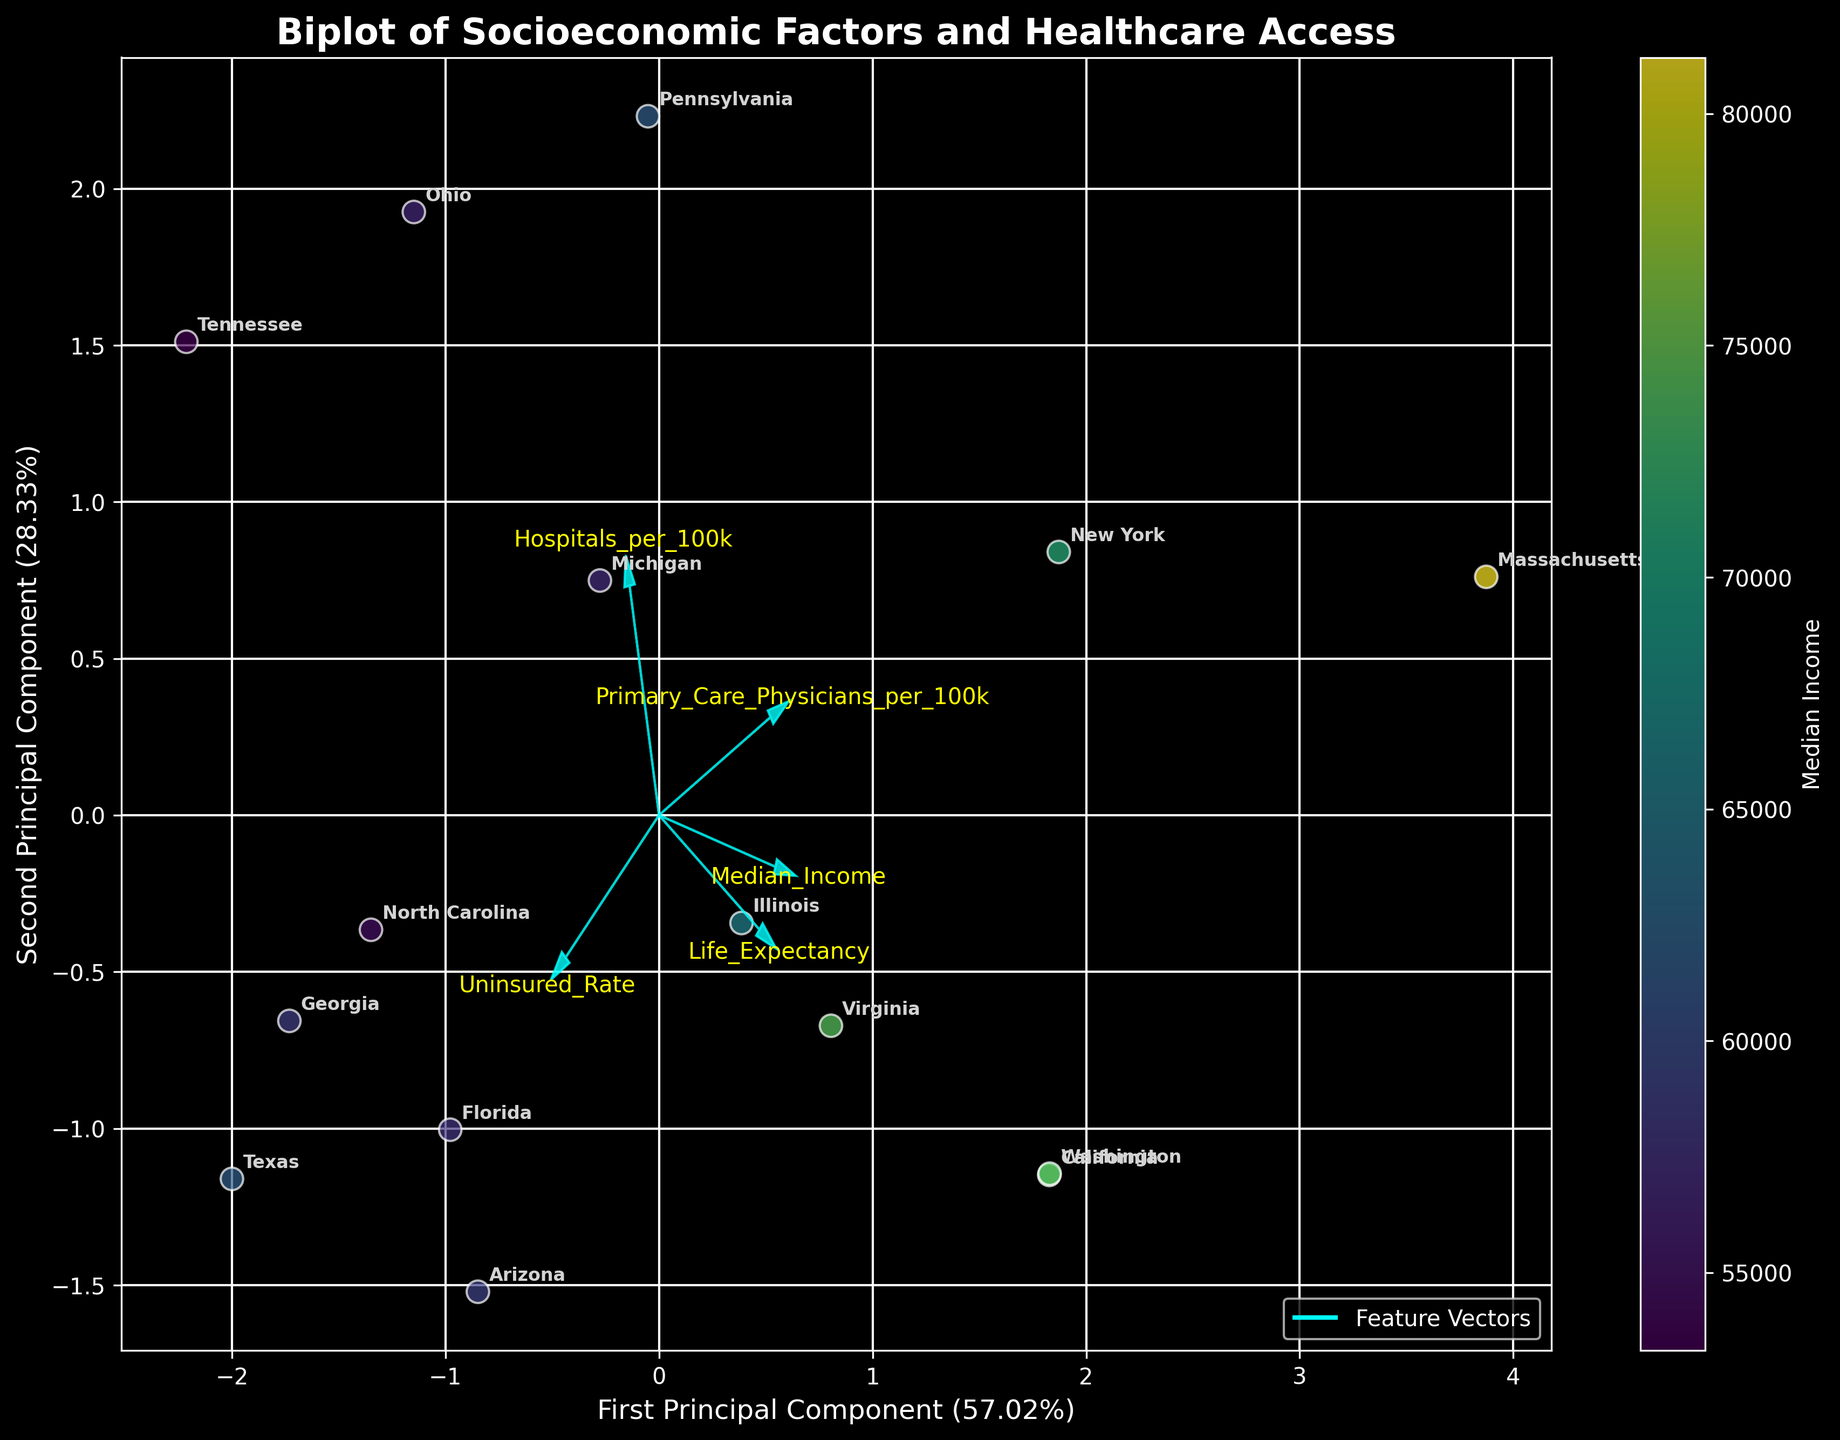What's the title of the biplot? The title is prominently displayed at the top of the plot and reads "Biplot of Socioeconomic Factors and Healthcare Access".
Answer: Biplot of Socioeconomic Factors and Healthcare Access Which axis explains more variance, the first or the second principal component? The explained variance percentages are indicated in parentheses next to each axis label; the first principal component has a higher percentage.
Answer: First principal component How many states have been plotted in the biplot? Each state is marked on the plot with an annotation. Counting them gives the total number of states.
Answer: 15 Which state corresponds to the highest Median Income, and where is it located on the plot? The color of the points indicates median income. The brightest point (highest income) corresponds to Massachusetts, and its placement can be identified on the plot.
Answer: Massachusetts, near the top Which feature vector is the longest in the plot, indicating it has the highest contribution to variability? The lengths of the arrows representing feature vectors indicate their contribution. The longest arrow corresponds to "Primary_Care_Physicians_per_100k".
Answer: Primary_Care_Physicians_per_100k Which states are closest to each other on the first principal component? Check the horizontal coordinates of the annotated state labels and identify states with similar first principal component values.
Answer: Ohio and Pennsylvania What relationship can you infer between 'Median Income' and 'Life Expectancy' based on the feature vectors? To determine this, examine the directions of the 'Median Income' and 'Life Expectancy' vectors; if they point in the same direction, it indicates a positive correlation.
Answer: Positive correlation Which state has the highest Uninsured Rate and where is it located in the biplot? By referring to the original data, Texas has the highest Uninsured Rate. Locate Texas on the plot by finding its annotation.
Answer: Texas, towards the left What is the range of the "Median Income" visible from the color bar in the biplot? The color bar shows the "Median Income" gradient. Reading the minimum and maximum values from it tells the range.
Answer: Approximately 53,000 to 81,000 What does the color of the points in the biplot represent, and how can you tell? The color bar labeled "Median Income" next to the plot explains what the color represents.
Answer: Median Income 